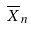Convert formula to latex. <formula><loc_0><loc_0><loc_500><loc_500>\overline { X } _ { n }</formula> 